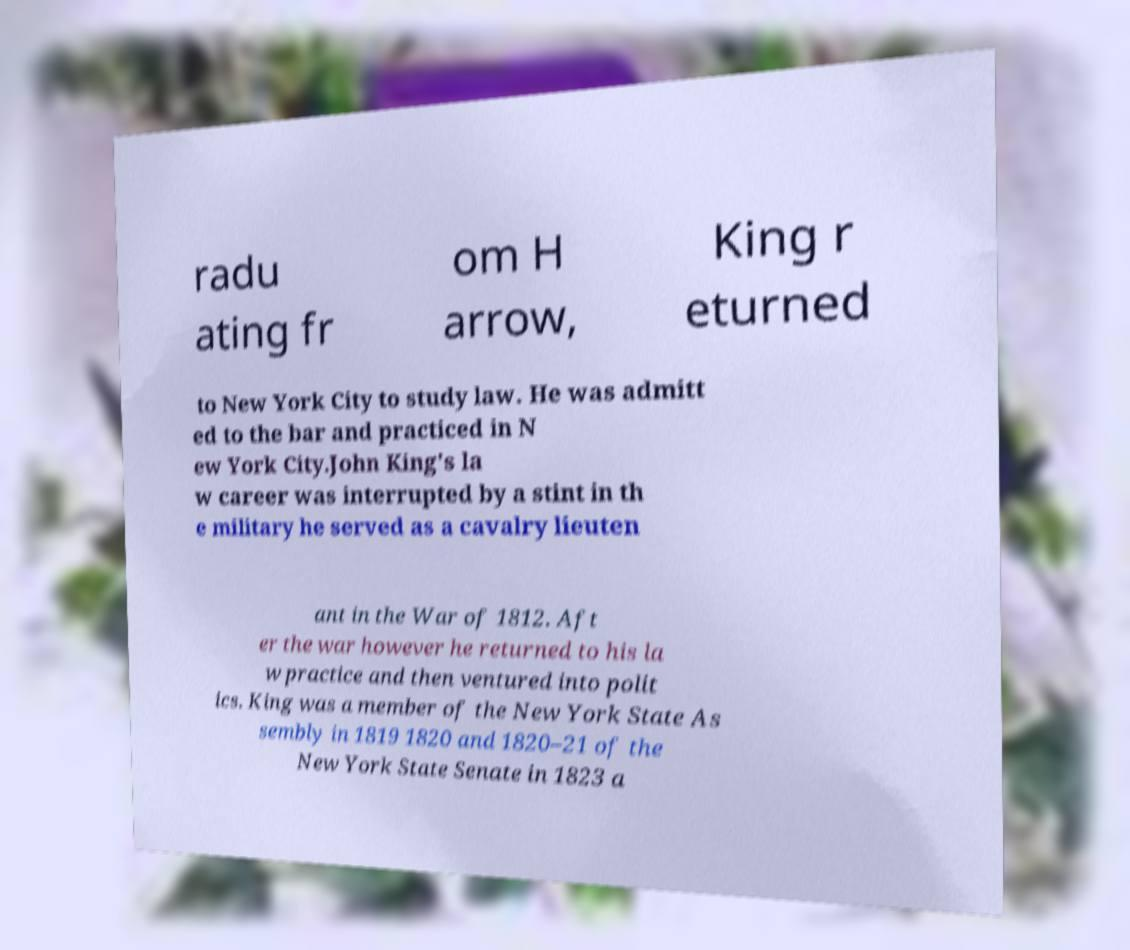Could you assist in decoding the text presented in this image and type it out clearly? radu ating fr om H arrow, King r eturned to New York City to study law. He was admitt ed to the bar and practiced in N ew York City.John King's la w career was interrupted by a stint in th e military he served as a cavalry lieuten ant in the War of 1812. Aft er the war however he returned to his la w practice and then ventured into polit ics. King was a member of the New York State As sembly in 1819 1820 and 1820–21 of the New York State Senate in 1823 a 